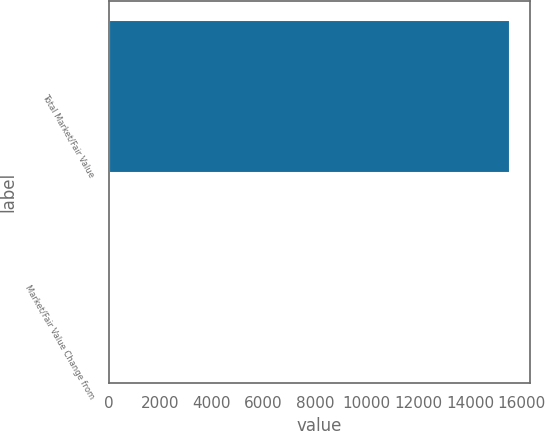Convert chart. <chart><loc_0><loc_0><loc_500><loc_500><bar_chart><fcel>Total Market/Fair Value<fcel>Market/Fair Value Change from<nl><fcel>15563.2<fcel>5.1<nl></chart> 